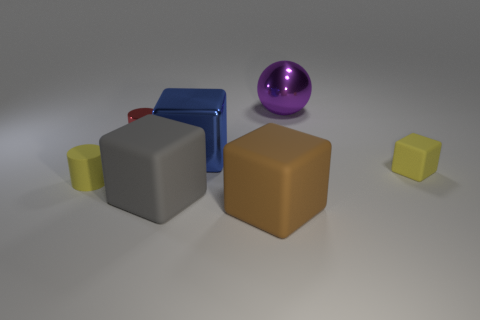Do the yellow cylinder and the red metallic cylinder have the same size?
Offer a terse response. Yes. Are any small objects visible?
Provide a short and direct response. Yes. What size is the rubber object that is the same color as the small rubber cube?
Keep it short and to the point. Small. There is a matte block left of the large metallic object that is in front of the big metallic object behind the small metal cylinder; how big is it?
Your answer should be compact. Large. How many purple things have the same material as the tiny yellow cube?
Your answer should be compact. 0. What number of yellow matte blocks have the same size as the shiny ball?
Provide a short and direct response. 0. There is a tiny thing behind the yellow rubber object behind the yellow rubber object that is to the left of the purple metal thing; what is its material?
Provide a succinct answer. Metal. How many things are big matte objects or brown blocks?
Your response must be concise. 2. Is there anything else that has the same material as the yellow cylinder?
Your answer should be compact. Yes. The big gray rubber object is what shape?
Your answer should be very brief. Cube. 